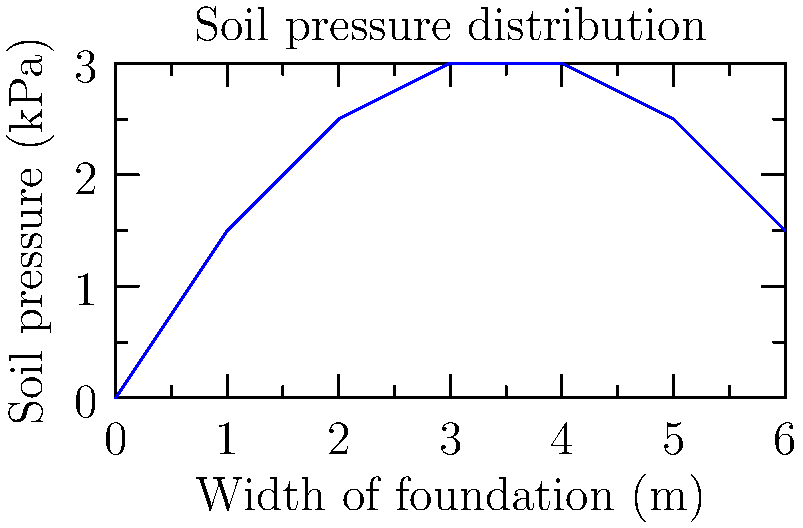As a novelist exploring the intricacies of foundation engineering for a character in your latest book, you come across a graph depicting the soil pressure distribution beneath a shallow foundation. The graph shows a non-uniform pressure distribution. What type of foundation settlement does this pressure distribution typically indicate? To answer this question, let's analyze the pressure distribution graph step-by-step:

1. Observe the shape of the pressure distribution curve:
   - It is not uniform across the width of the foundation.
   - The pressure is higher in the middle and lower at the edges.

2. Understand the implications of this pressure distribution:
   - A uniform pressure distribution would indicate even settlement.
   - Higher pressure in the middle suggests more settlement in the center.

3. Consider the types of foundation settlement:
   - Uniform settlement: Even pressure distribution
   - Differential settlement: Uneven pressure distribution

4. Analyze the consequences of this pressure distribution:
   - The center of the foundation experiences more pressure.
   - This leads to more settlement in the middle compared to the edges.

5. Conclude the type of settlement:
   - The non-uniform pressure distribution with higher pressure in the middle typically indicates differential settlement.

6. Understand the implications for the structure:
   - Differential settlement can cause structural issues like cracking or tilting.

Therefore, the pressure distribution shown in the graph typically indicates differential settlement of the foundation.
Answer: Differential settlement 